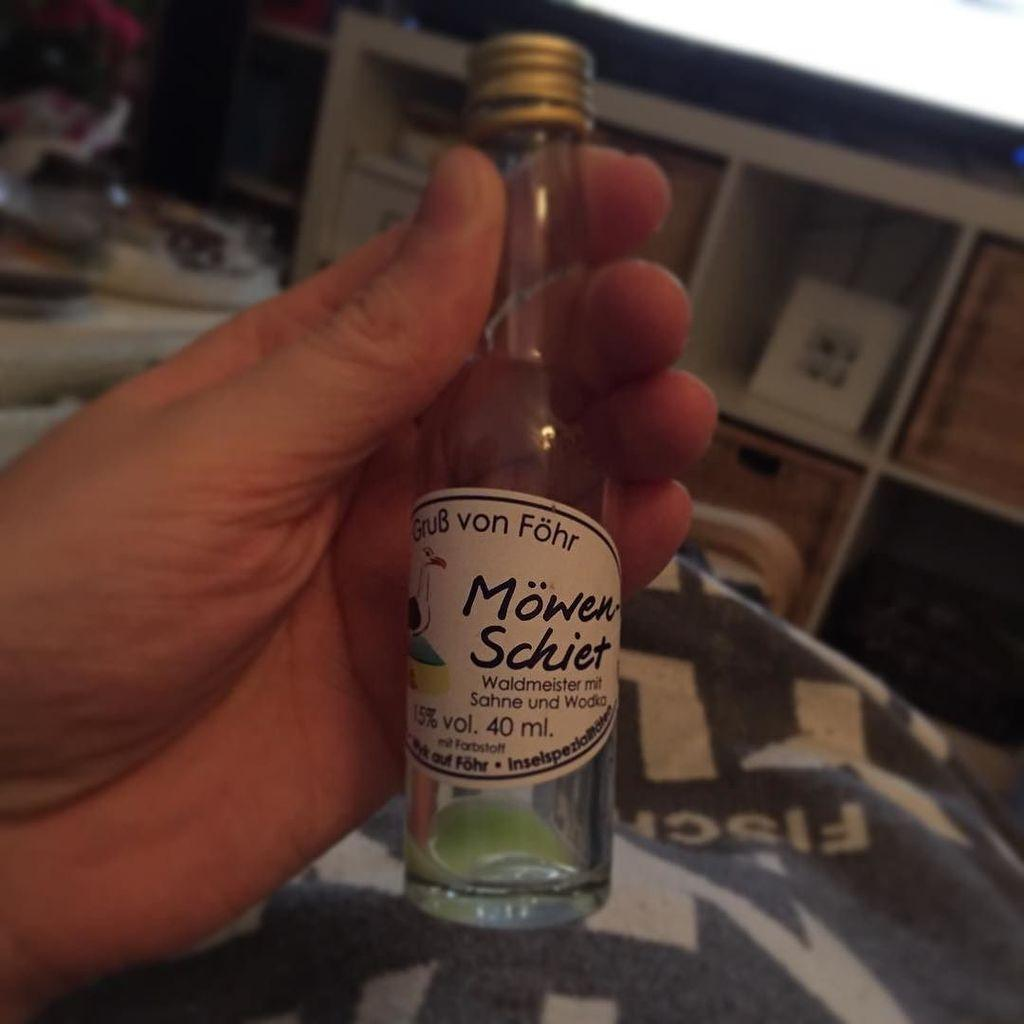Provide a one-sentence caption for the provided image. A hand is holding a small bottle of Waldmeister mit Sahne und Wodka. 